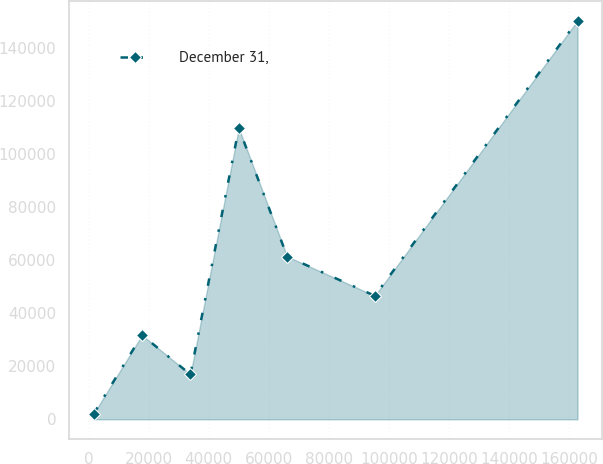Convert chart. <chart><loc_0><loc_0><loc_500><loc_500><line_chart><ecel><fcel>December 31,<nl><fcel>1669.22<fcel>2093.21<nl><fcel>17776.3<fcel>31764.3<nl><fcel>33883.4<fcel>16928.8<nl><fcel>49990.5<fcel>109916<nl><fcel>66097.6<fcel>61435.4<nl><fcel>95271.9<fcel>46599.9<nl><fcel>162740<fcel>150449<nl></chart> 